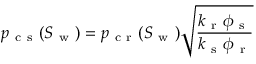<formula> <loc_0><loc_0><loc_500><loc_500>p _ { c s } ( S _ { w } ) = p _ { c r } ( S _ { w } ) \sqrt { \frac { k _ { r } \phi _ { s } } { k _ { s } \phi _ { r } } }</formula> 